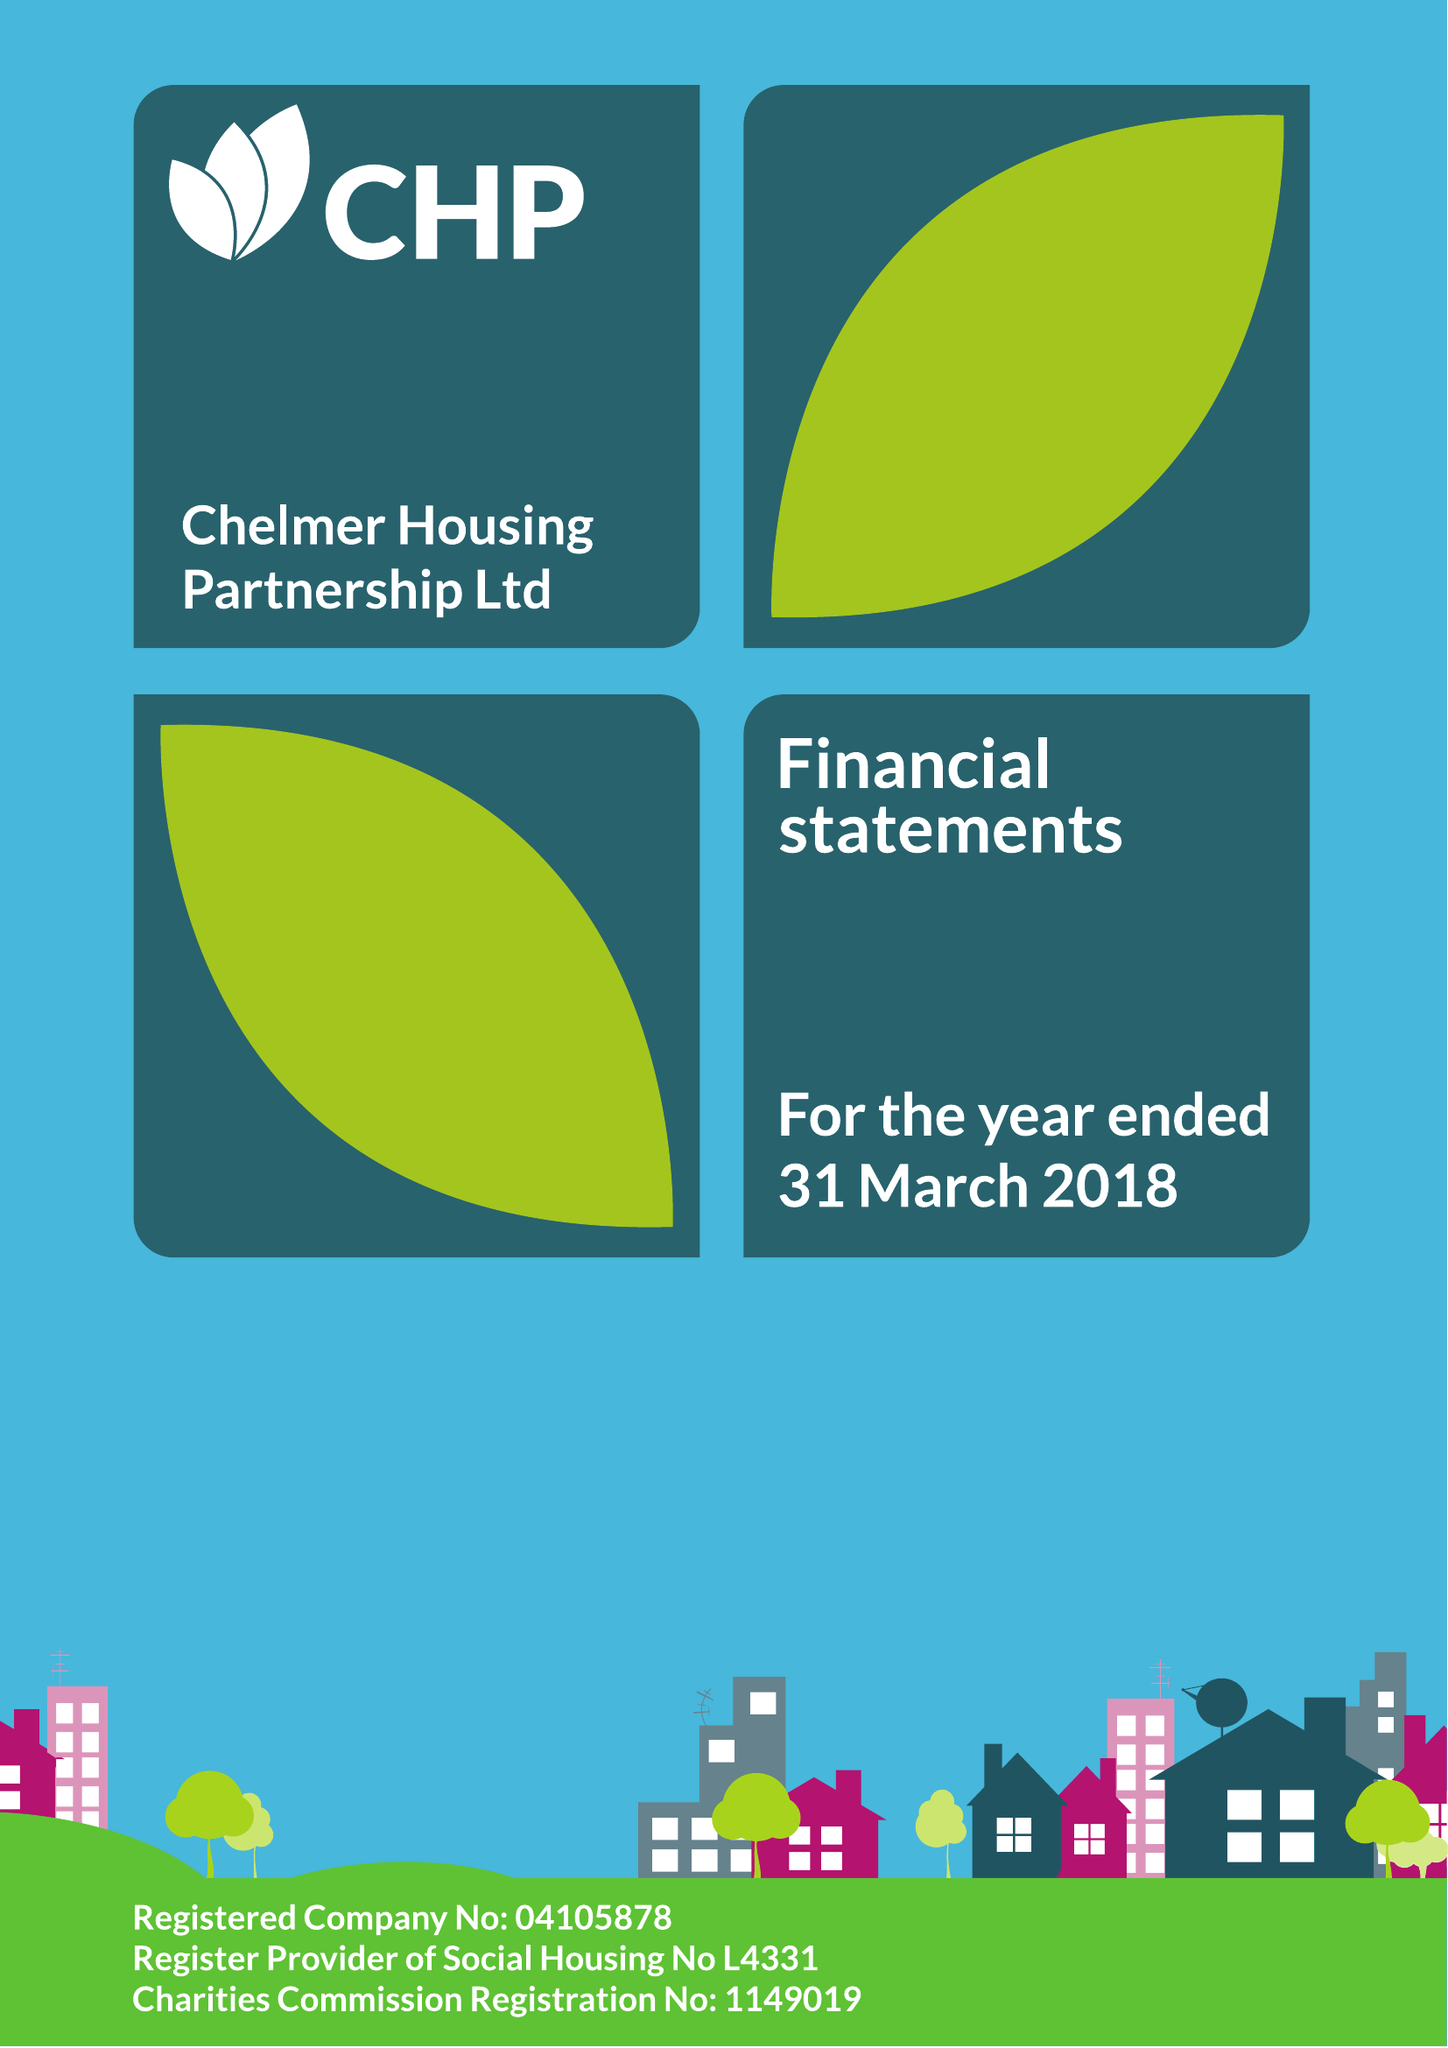What is the value for the charity_number?
Answer the question using a single word or phrase. 1149019 